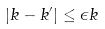Convert formula to latex. <formula><loc_0><loc_0><loc_500><loc_500>| k - k ^ { \prime } | \leq \epsilon k</formula> 